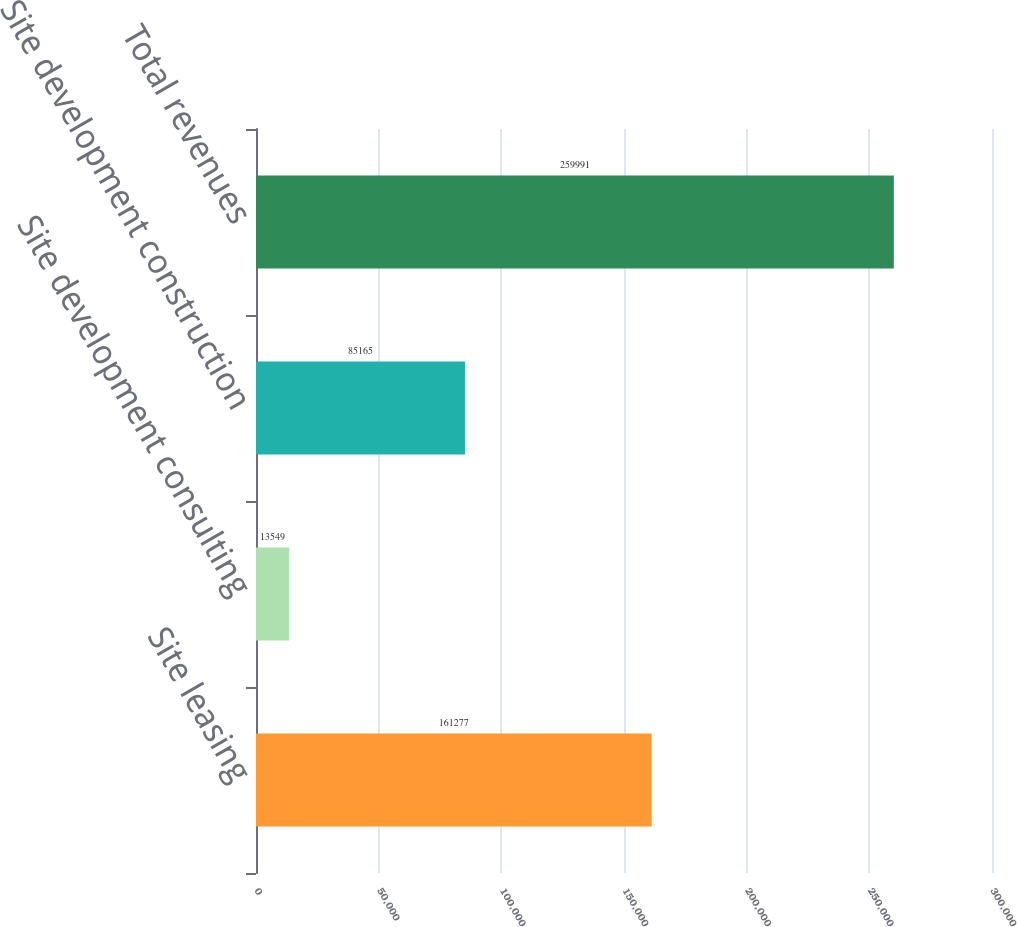Convert chart to OTSL. <chart><loc_0><loc_0><loc_500><loc_500><bar_chart><fcel>Site leasing<fcel>Site development consulting<fcel>Site development construction<fcel>Total revenues<nl><fcel>161277<fcel>13549<fcel>85165<fcel>259991<nl></chart> 